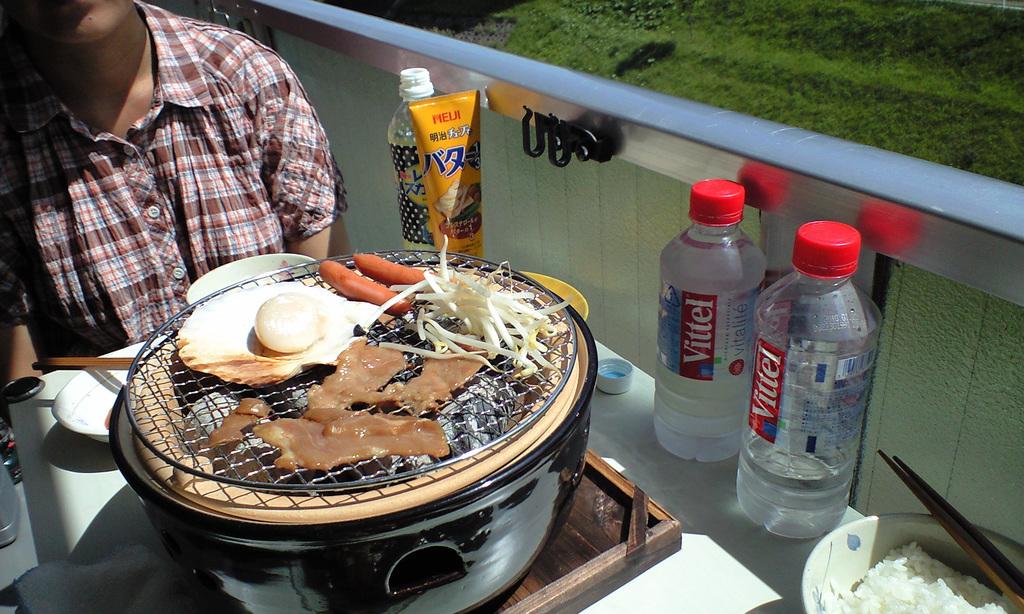What brand water is on the right?
Provide a short and direct response. Vittel. 